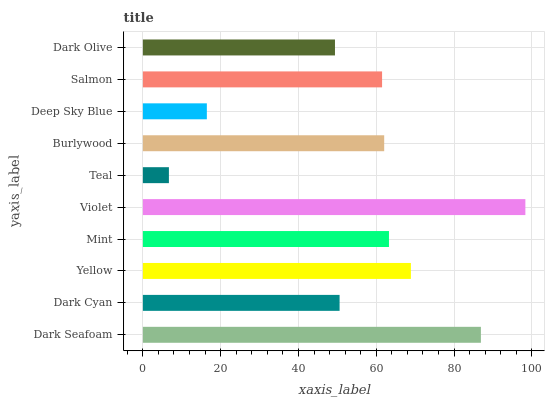Is Teal the minimum?
Answer yes or no. Yes. Is Violet the maximum?
Answer yes or no. Yes. Is Dark Cyan the minimum?
Answer yes or no. No. Is Dark Cyan the maximum?
Answer yes or no. No. Is Dark Seafoam greater than Dark Cyan?
Answer yes or no. Yes. Is Dark Cyan less than Dark Seafoam?
Answer yes or no. Yes. Is Dark Cyan greater than Dark Seafoam?
Answer yes or no. No. Is Dark Seafoam less than Dark Cyan?
Answer yes or no. No. Is Burlywood the high median?
Answer yes or no. Yes. Is Salmon the low median?
Answer yes or no. Yes. Is Yellow the high median?
Answer yes or no. No. Is Yellow the low median?
Answer yes or no. No. 